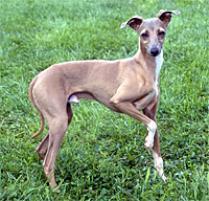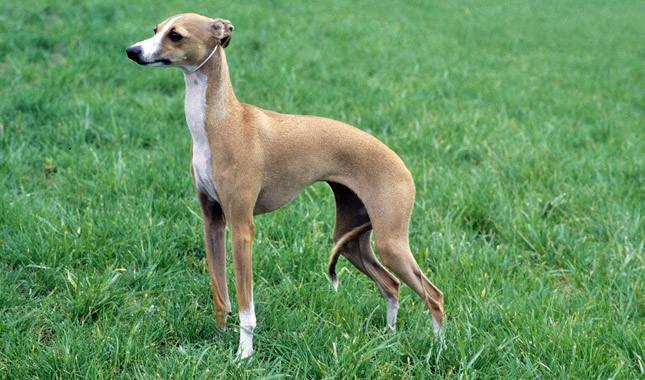The first image is the image on the left, the second image is the image on the right. Considering the images on both sides, is "the dog in the image on the right has its tail tucked between its legs" valid? Answer yes or no. Yes. 